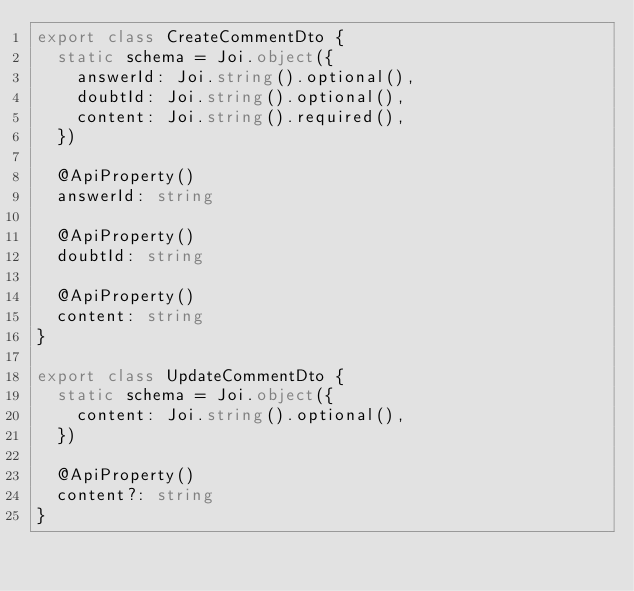Convert code to text. <code><loc_0><loc_0><loc_500><loc_500><_TypeScript_>export class CreateCommentDto {
  static schema = Joi.object({
    answerId: Joi.string().optional(),
    doubtId: Joi.string().optional(),
    content: Joi.string().required(),
  })

  @ApiProperty()
  answerId: string

  @ApiProperty()
  doubtId: string

  @ApiProperty()
  content: string
}

export class UpdateCommentDto {
  static schema = Joi.object({
    content: Joi.string().optional(),
  })

  @ApiProperty()
  content?: string
}
</code> 